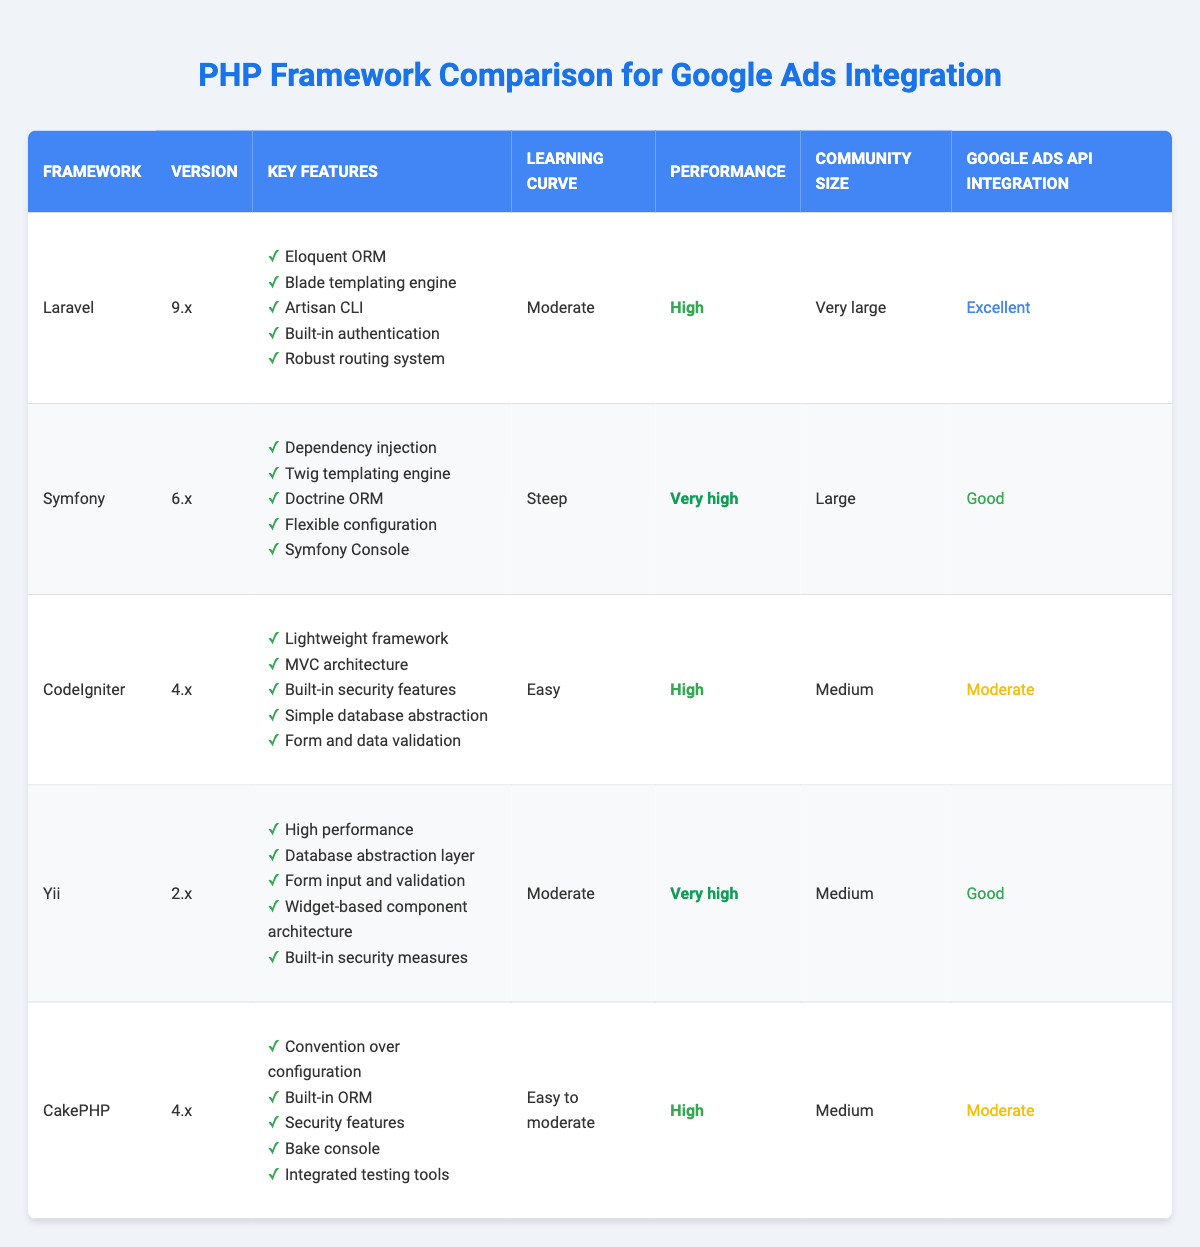What is the version of the Laravel framework? The version of Laravel can be found in the "Version" column corresponding to the "Laravel" row in the table. It is listed as "9.x".
Answer: 9.x Which framework has the highest performance rating? To determine the highest performance rating, I compare the performance ratings of all frameworks listed in the table. Symfony and Yii both have a performance rating of "Very high", which is the best available rating.
Answer: Symfony and Yii Does CodeIgniter have built-in authentication features? The "Key Features" column for CodeIgniter lists its features. Checking this list shows that it does not include built-in authentication features. Therefore, the answer is no.
Answer: No Which framework has built-in security features listed as a key feature? I review the "Key Features" for each framework, focusing on security. Both CodeIgniter and CakePHP list "Built-in security features" and "Security features," respectively, indicating they have such features.
Answer: CodeIgniter and CakePHP How many frameworks have a "Moderate" learning curve? I count the number of frameworks in the "Learning Curve" column that are labeled as "Moderate." There are three frameworks: Laravel, Yii, and CakePHP, totaling three.
Answer: 3 Is it true that CakePHP has a very large community size? The "Community Size" for CakePHP indicates it has a "Medium" community size. Therefore, it is not true that CakePHP has a very large community size.
Answer: No Which frameworks have "Good" integration with Google Ads API? By checking the "Google Ads API Integration" column, I can see that Symfony and Yii are both labeled as "Good" for their integration.
Answer: Symfony and Yii What is the average performance rating for all frameworks? The performance ratings listed are High, Very high, Easy, High, and Very high. In a qualitative sense, we can assign values: High (1), Very High (2), Moderate (0). The average is calculated based on these values: (1+2+1+2+1)/5 = 1.4, which translates to a performance of High on average.
Answer: High Which framework has the smallest community size? By reviewing the "Community Size" column, I find that CodeIgniter, Yii, and CakePHP all have a "Medium" community size, while Symfony has a "Large" community size, leaving Laravel with a "Very large" community size. All frameworks have at least a medium community size, thus there is no smallest framework.
Answer: None 